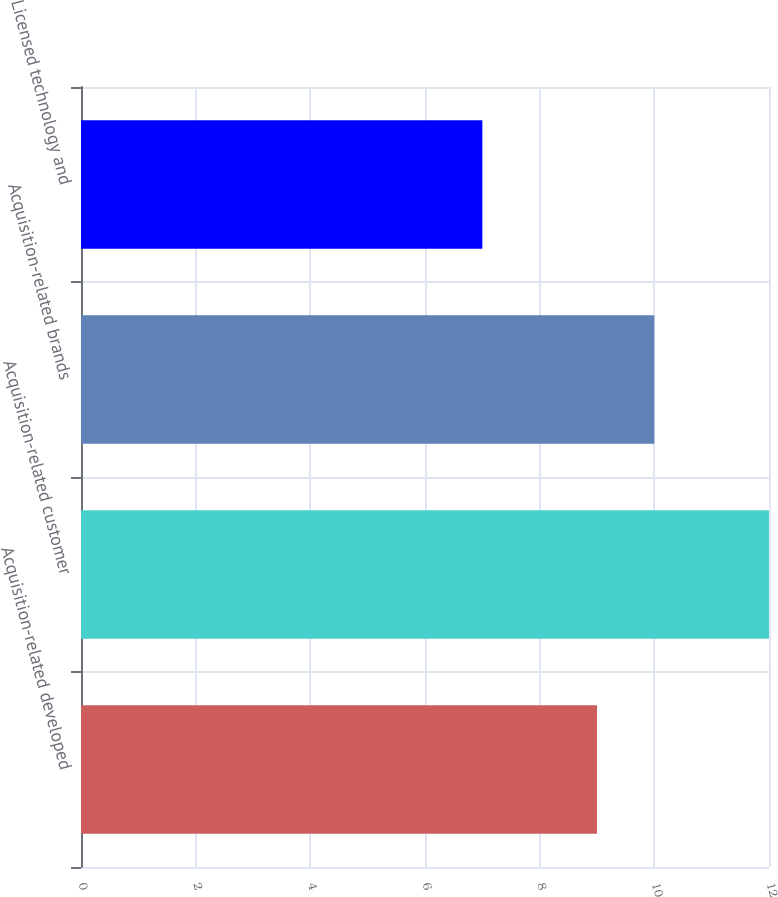Convert chart to OTSL. <chart><loc_0><loc_0><loc_500><loc_500><bar_chart><fcel>Acquisition-related developed<fcel>Acquisition-related customer<fcel>Acquisition-related brands<fcel>Licensed technology and<nl><fcel>9<fcel>12<fcel>10<fcel>7<nl></chart> 